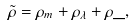<formula> <loc_0><loc_0><loc_500><loc_500>\tilde { \rho } = { \rho } _ { m } + { \rho } _ { \lambda } + { \rho } \_ ,</formula> 